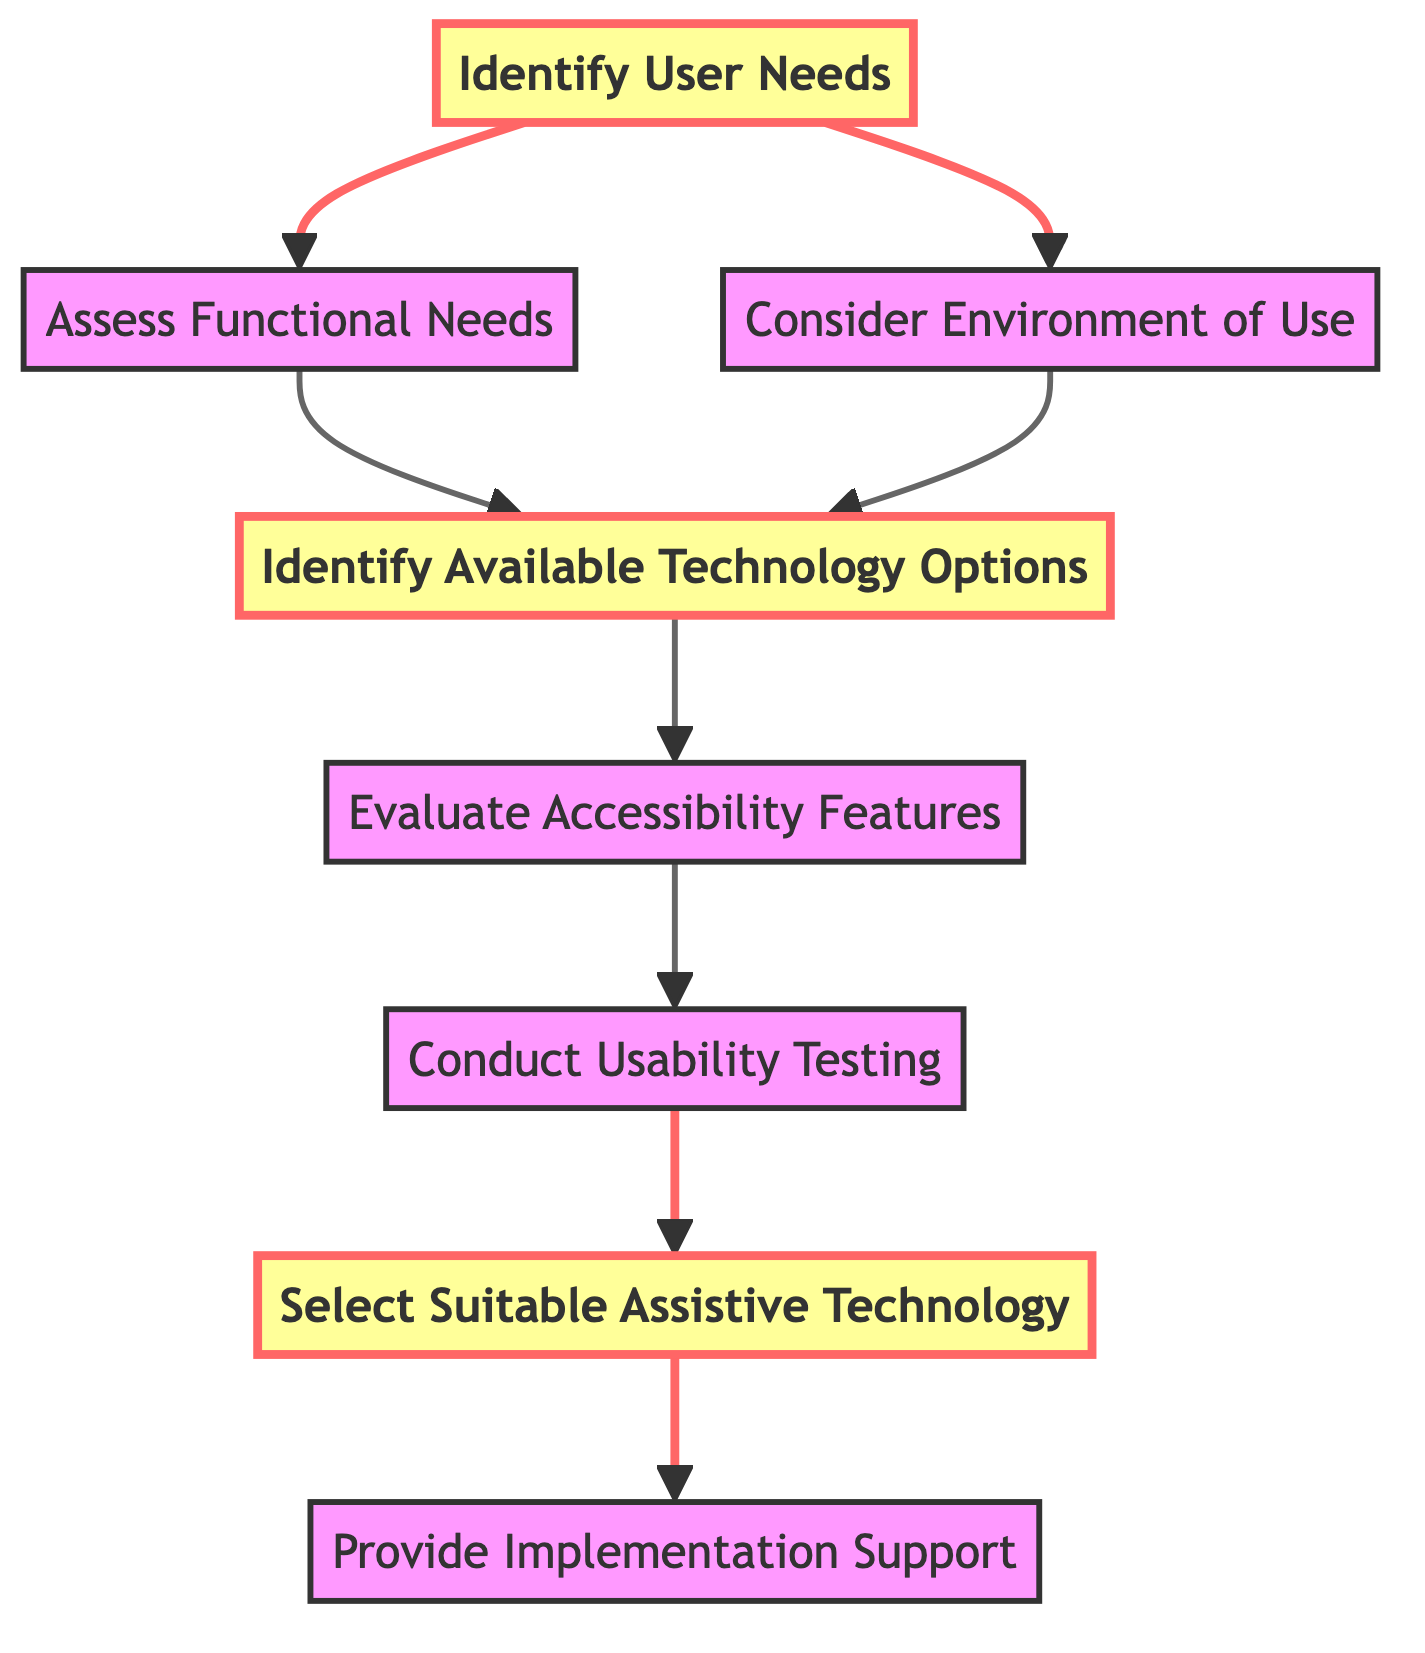What is the first step in the diagram? The first step is represented by the node labeled "Identify User Needs," which is the starting point of the decision-making flowchart.
Answer: Identify User Needs How many nodes are present in the diagram? Counting all the individual steps or stages outlined in the nodes, we find there are a total of 8 nodes in the diagram.
Answer: 8 Which node follows "Evaluate Accessibility Features"? The node that directly follows "Evaluate Accessibility Features" in the flowchart is "Conduct Usability Testing," indicating the next step in the process.
Answer: Conduct Usability Testing What is the last step in the flowchart? The last step is represented by the node labeled "Provide Implementation Support," which concludes the decision-making process.
Answer: Provide Implementation Support What two nodes are connected to "Identify User Needs"? The nodes connected to "Identify User Needs" are "Assess Functional Needs" and "Consider Environment of Use." This indicates the branching stages after identifying user needs.
Answer: Assess Functional Needs, Consider Environment of Use Which node has multiple incoming edges? The node "Technology Options" has incoming edges from both "Assess Functional Needs" and "Consider Environment of Use," indicating that both assessments contribute to identifying technology options.
Answer: Technology Options What step comes after "Select Suitable Assistive Technology"? Following "Select Suitable Assistive Technology," the next step is "Provide Implementation Support," indicating a progression towards supporting the chosen technology.
Answer: Provide Implementation Support Identify a key emphasis in the diagram. The key emphasized nodes in the diagram are "Identify User Needs," "Identify Available Technology Options," and "Select Suitable Assistive Technology," which are highlighted to signify their importance in the process.
Answer: Identify User Needs, Identify Available Technology Options, Select Suitable Assistive Technology What two criteria lead into "Identify Available Technology Options"? The criteria leading into "Identify Available Technology Options" are "Assess Functional Needs" and "Consider Environment of Use," showcasing the factors that determine technology options available for the user.
Answer: Assess Functional Needs, Consider Environment of Use 